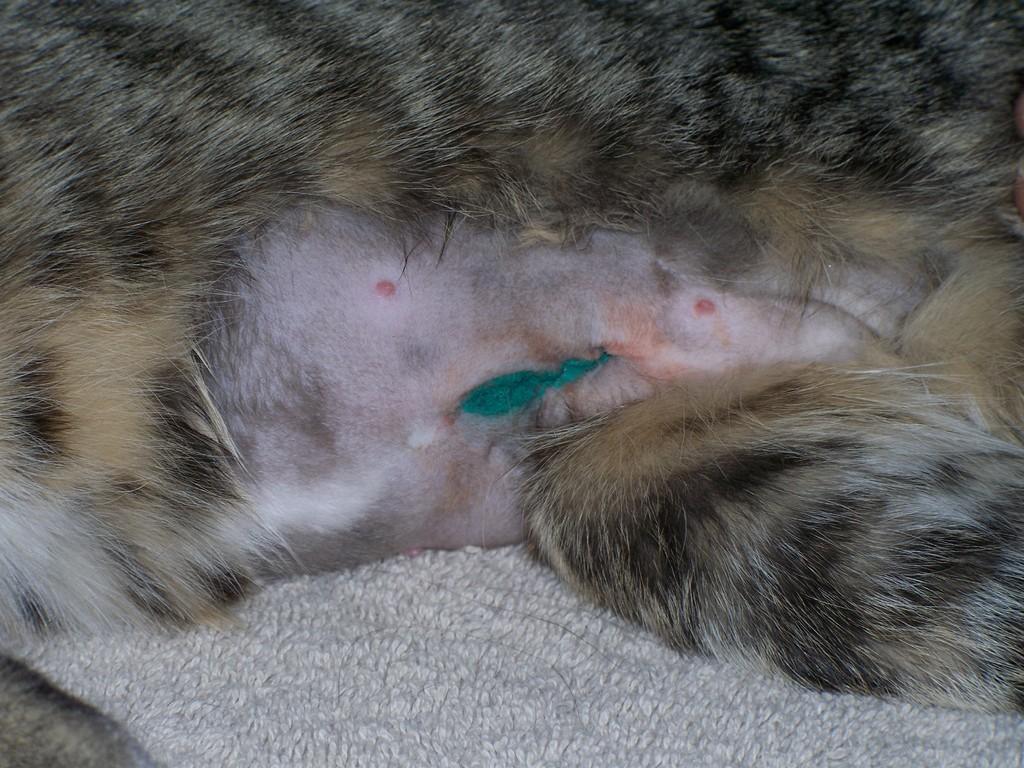Please provide a concise description of this image. This is a zoomed in picture and we can see an animal seems to be sitting on an object. 